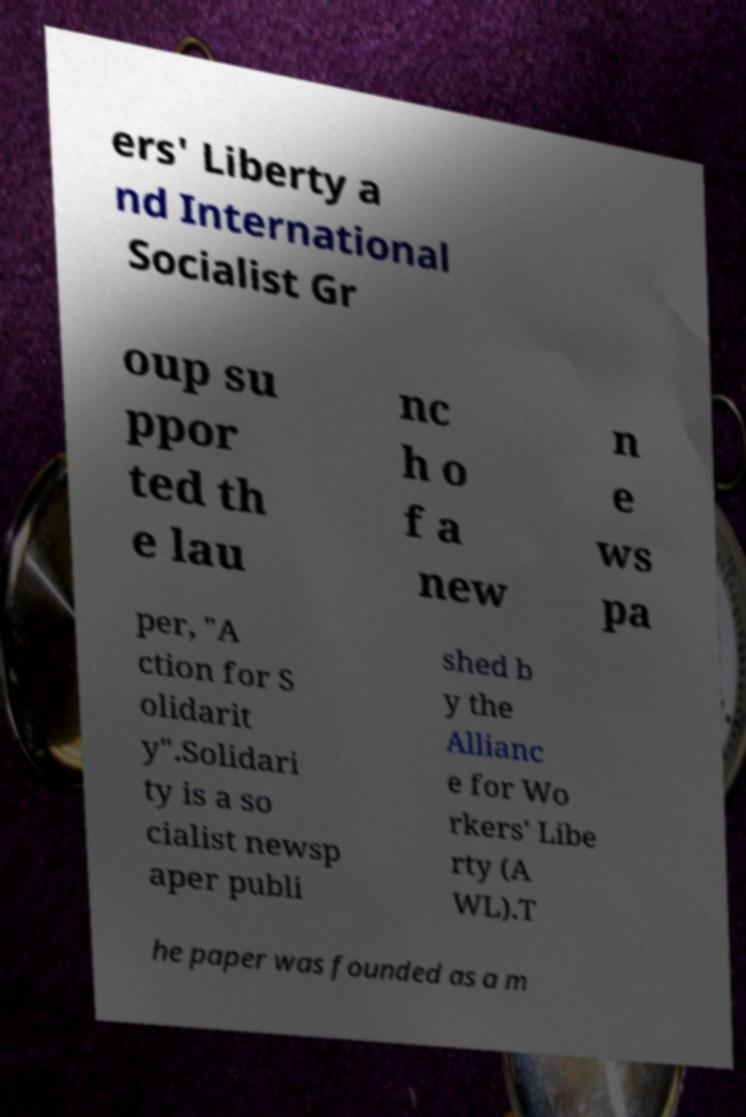Can you read and provide the text displayed in the image?This photo seems to have some interesting text. Can you extract and type it out for me? ers' Liberty a nd International Socialist Gr oup su ppor ted th e lau nc h o f a new n e ws pa per, "A ction for S olidarit y".Solidari ty is a so cialist newsp aper publi shed b y the Allianc e for Wo rkers' Libe rty (A WL).T he paper was founded as a m 